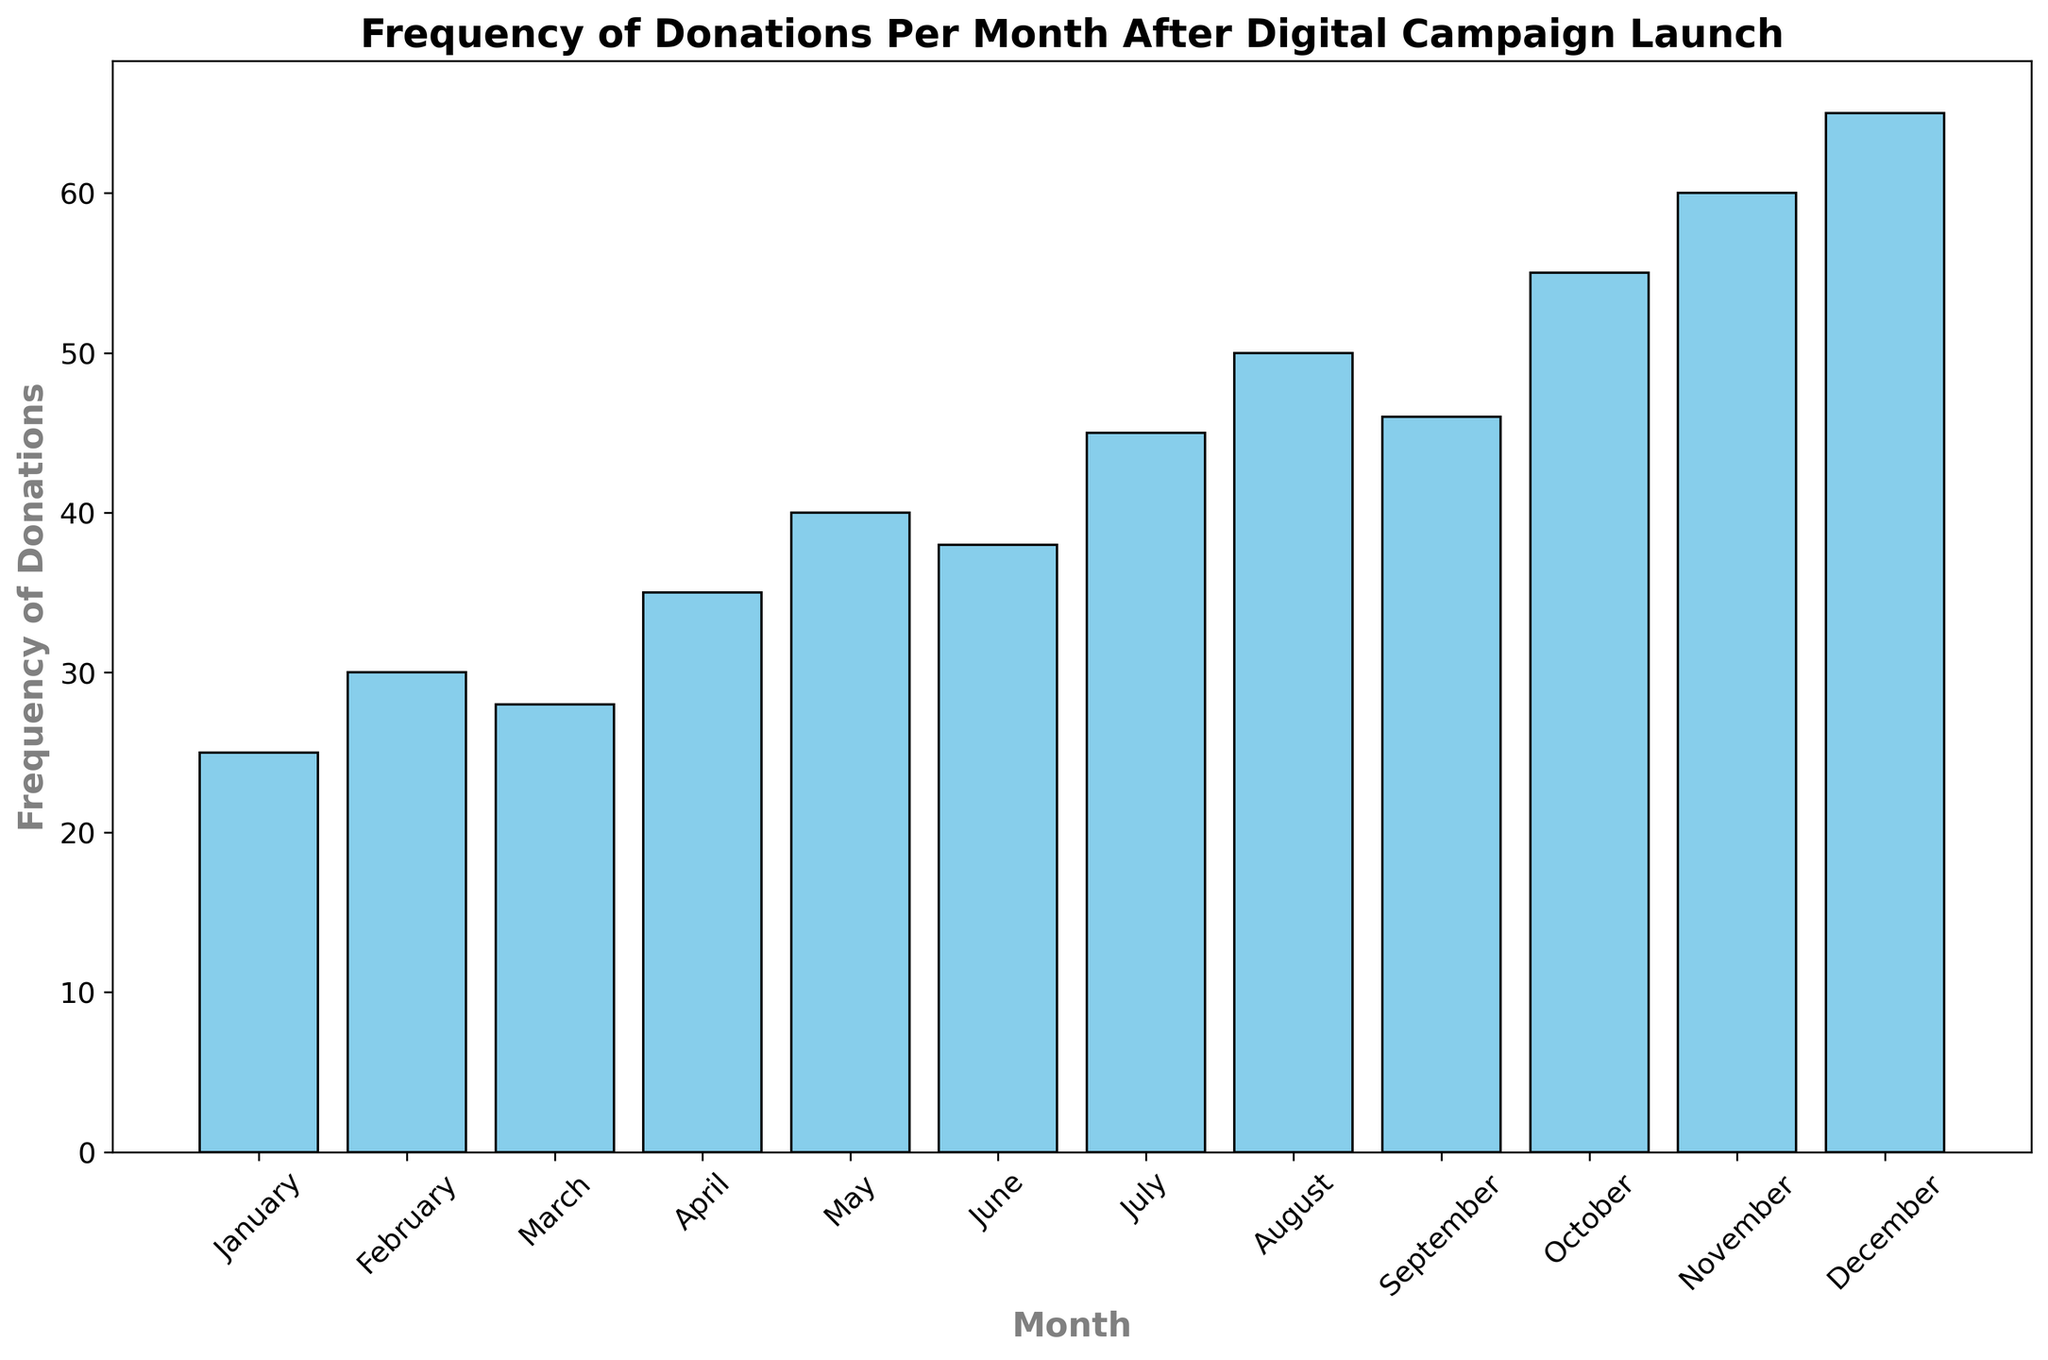what's the average frequency of donations in the second quarter? The second quarter includes April, May, and June. Sum their frequency of donations (35 + 40 + 38 = 113). There are three months, so the average is 113 / 3 ≈ 37.67
Answer: 37.67 how does December compare to July in terms of donation frequency? December has 65 donations, and July has 45 donations. To compare, subtract July's donations from December's (65 - 45 = 20). December has 20 more donations than July.
Answer: 20 more which month shows the highest frequency of donations? From the visual data, December has the tallest bar, indicating it has the highest frequency of donations, which is 65
Answer: December what is the total frequency of donations for the last quarter? The last quarter includes October, November, and December. Sum their frequency of donations (55 + 60 + 65 = 180)
Answer: 180 which month experienced the lowest donation frequency and what was it? From the visual data, January has the shortest bar, indicating it has the lowest donation frequency, which is 25
Answer: January, 25 is there a month where the frequency jumped significantly compared to the previous month? Comparing month-by-month, the most significant jump is from September (46) to October (55). The increase is 55 - 46 = 9
Answer: September to October, 9 what's the median frequency of donations across all months? The frequencies sorted are: 25, 28, 30, 35, 38, 40, 45, 46, 50, 55, 60, 65. With 12 data points, the median is the average of the 6th and 7th values (40 and 45). So, (40 + 45) / 2 = 42.5
Answer: 42.5 compare the total donations in the first half of the year to the second half. Sum the donations for January through June (25 + 30 + 28 + 35 + 40 + 38 = 196) and for July through December (45 + 50 + 46 + 55 + 60 + 65 = 321). The second half has more donations: 321 - 196 = 125 more
Answer: 125 more describe the trend in donation frequency from January to December. The trend shows a general increase in donations from January (25) to December (65), suggesting a positive impact of the digital campaign
Answer: Increasing trend 